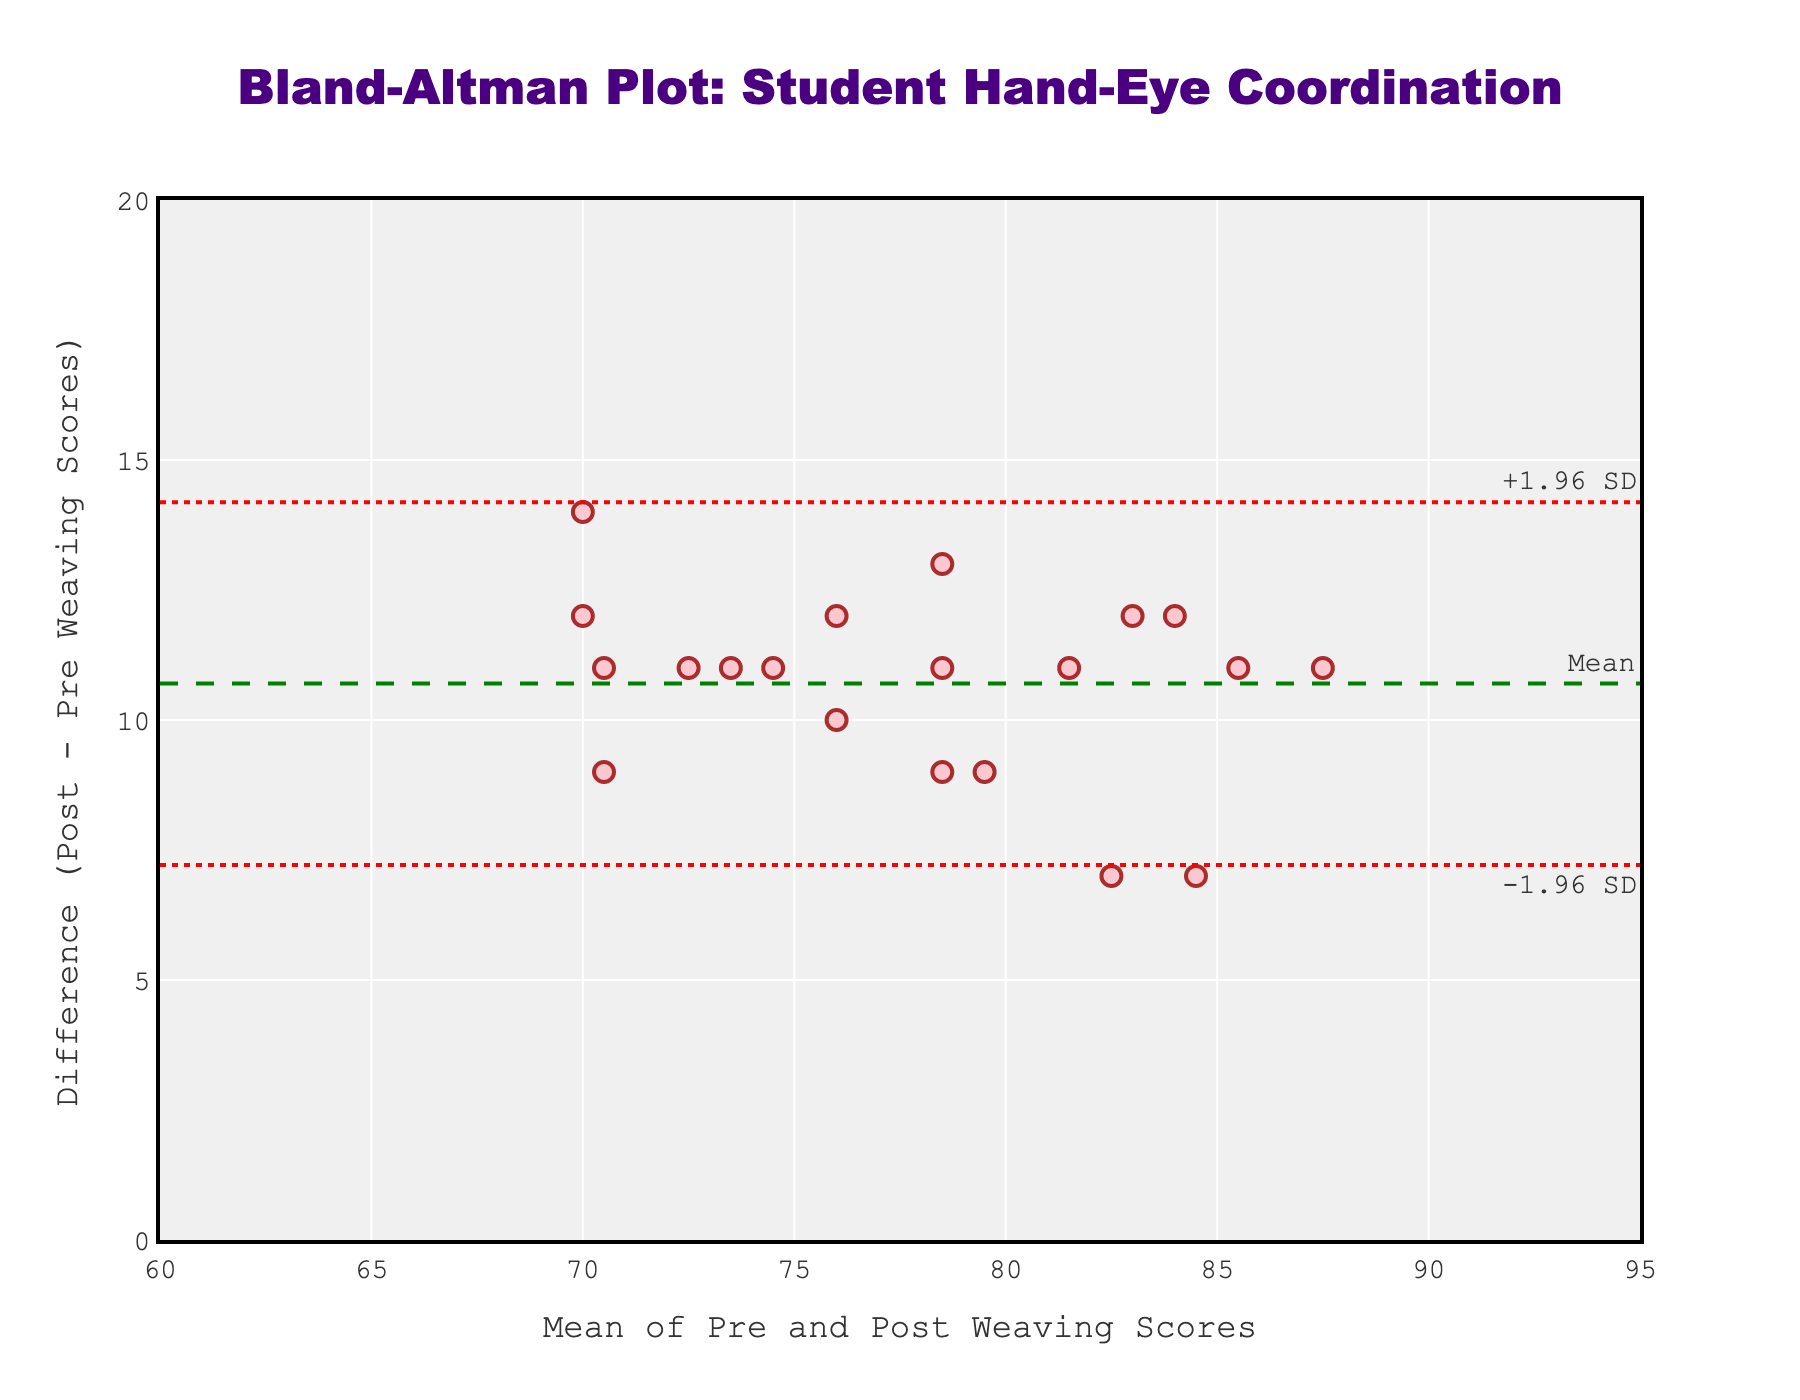what is the title of the figure? The title is displayed at the top of the plot. Refer to the largest text typically centered at the top. In this case, it says "Bland-Altman Plot: Student Hand-Eye Coordination".
Answer: Bland-Altman Plot: Student Hand-Eye Coordination what are the x-axis and y-axis labels? The labels for the axes are displayed next to each respective axis. The x-axis is labeled "Mean of Pre and Post Weaving Scores" and the y-axis is labeled "Difference (Post - Pre Weaving Scores)".
Answer: Mean of Pre and Post Weaving Scores, Difference (Post - Pre Weaving Scores) how many student data points are in the plot? Count the number of individual markers scattered on the plot. Each marker represents one student's data. There are 20 scattered markers.
Answer: 20 what is the mean difference between the pre- and post-weaving scores? The mean difference is represented by the green dashed line, annotated as "Mean". This line is positioned at a specific value on the y-axis. The mean difference is 11.
Answer: 11 what is the range between the upper and lower limits of agreement lines? Identify the values of the upper and lower red dotted lines. The upper limit is at 16.88 and the lower limit is at 5.12. Subtract the lower limit from the upper limit (16.88 - 5.12).
Answer: 11.76 which student has the highest mean score? Check the x-axis values to find the highest mean score. The dot with the highest x-axis value corresponds to the student with the highest mean score. This value roughly appears to be around 87.5, corresponding to Evelyn.
Answer: Evelyn what is the difference between Charlotte's pre-and post-weaving scores? Find Charlotte’s data point and read its position relative to the y-axis. The dot's y-axis value represents the difference in her scores. The difference is around 11.
Answer: 11 are any student differences outside the limits of agreement? Look at the plot to see if any dots (student data points) are outside the red dotted lines (limits of agreement). All points lie within the range from 5.12 to 16.88.
Answer: No what color are the student data points on the plot? Observe the color of the markers representing the student scores on the plot. The markers are colored in a shade of pink.
Answer: Pink how does the mean difference line compare to the limits of agreement lines? The mean difference line is drawn in the middle as a green dashed line, while the limits of agreement are red dotted lines positioned equidistant from the mean line, above and below it.
Answer: The mean difference line is centered between the limits of agreement 